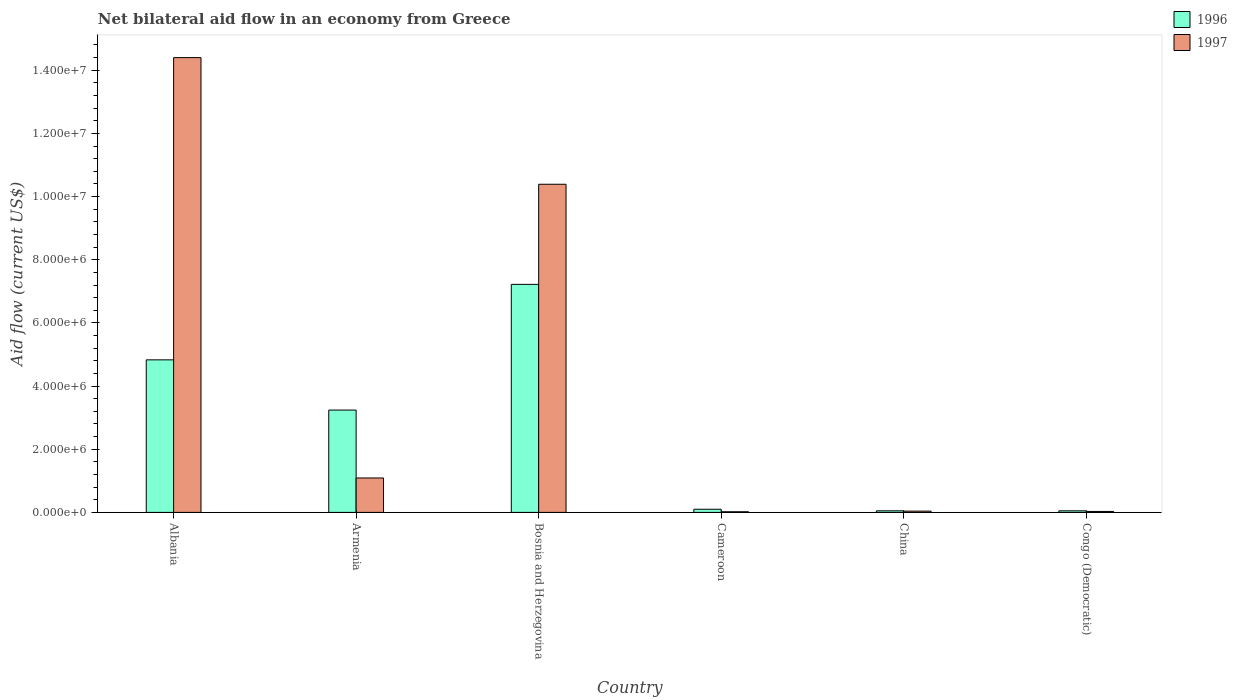How many different coloured bars are there?
Offer a very short reply. 2. How many groups of bars are there?
Your answer should be very brief. 6. Are the number of bars per tick equal to the number of legend labels?
Offer a very short reply. Yes. Are the number of bars on each tick of the X-axis equal?
Keep it short and to the point. Yes. How many bars are there on the 5th tick from the left?
Ensure brevity in your answer.  2. What is the label of the 5th group of bars from the left?
Offer a very short reply. China. In how many cases, is the number of bars for a given country not equal to the number of legend labels?
Keep it short and to the point. 0. What is the net bilateral aid flow in 1997 in Bosnia and Herzegovina?
Offer a very short reply. 1.04e+07. Across all countries, what is the maximum net bilateral aid flow in 1997?
Your answer should be compact. 1.44e+07. Across all countries, what is the minimum net bilateral aid flow in 1996?
Your answer should be very brief. 5.00e+04. In which country was the net bilateral aid flow in 1996 maximum?
Provide a succinct answer. Bosnia and Herzegovina. In which country was the net bilateral aid flow in 1996 minimum?
Provide a short and direct response. China. What is the total net bilateral aid flow in 1997 in the graph?
Offer a terse response. 2.60e+07. What is the difference between the net bilateral aid flow in 1997 in Armenia and that in Bosnia and Herzegovina?
Your answer should be compact. -9.30e+06. What is the difference between the net bilateral aid flow in 1996 in China and the net bilateral aid flow in 1997 in Armenia?
Provide a short and direct response. -1.04e+06. What is the average net bilateral aid flow in 1996 per country?
Your response must be concise. 2.58e+06. What is the difference between the net bilateral aid flow of/in 1997 and net bilateral aid flow of/in 1996 in Cameroon?
Provide a short and direct response. -8.00e+04. In how many countries, is the net bilateral aid flow in 1997 greater than 4800000 US$?
Keep it short and to the point. 2. What is the ratio of the net bilateral aid flow in 1997 in Albania to that in Cameroon?
Provide a succinct answer. 720. Is the net bilateral aid flow in 1997 in Cameroon less than that in China?
Make the answer very short. Yes. What is the difference between the highest and the second highest net bilateral aid flow in 1997?
Your answer should be very brief. 4.01e+06. What is the difference between the highest and the lowest net bilateral aid flow in 1996?
Your response must be concise. 7.17e+06. In how many countries, is the net bilateral aid flow in 1996 greater than the average net bilateral aid flow in 1996 taken over all countries?
Offer a terse response. 3. Is the sum of the net bilateral aid flow in 1997 in Armenia and Congo (Democratic) greater than the maximum net bilateral aid flow in 1996 across all countries?
Provide a short and direct response. No. What does the 2nd bar from the left in Bosnia and Herzegovina represents?
Give a very brief answer. 1997. How many bars are there?
Your answer should be very brief. 12. Are all the bars in the graph horizontal?
Your answer should be compact. No. Are the values on the major ticks of Y-axis written in scientific E-notation?
Provide a succinct answer. Yes. Does the graph contain any zero values?
Offer a terse response. No. Does the graph contain grids?
Offer a very short reply. No. How are the legend labels stacked?
Offer a terse response. Vertical. What is the title of the graph?
Your answer should be compact. Net bilateral aid flow in an economy from Greece. Does "2001" appear as one of the legend labels in the graph?
Your answer should be compact. No. What is the label or title of the X-axis?
Provide a short and direct response. Country. What is the label or title of the Y-axis?
Give a very brief answer. Aid flow (current US$). What is the Aid flow (current US$) of 1996 in Albania?
Your answer should be compact. 4.83e+06. What is the Aid flow (current US$) of 1997 in Albania?
Provide a short and direct response. 1.44e+07. What is the Aid flow (current US$) in 1996 in Armenia?
Offer a very short reply. 3.24e+06. What is the Aid flow (current US$) in 1997 in Armenia?
Give a very brief answer. 1.09e+06. What is the Aid flow (current US$) of 1996 in Bosnia and Herzegovina?
Provide a short and direct response. 7.22e+06. What is the Aid flow (current US$) of 1997 in Bosnia and Herzegovina?
Provide a succinct answer. 1.04e+07. What is the Aid flow (current US$) in 1997 in China?
Your response must be concise. 4.00e+04. What is the Aid flow (current US$) in 1996 in Congo (Democratic)?
Your answer should be very brief. 5.00e+04. Across all countries, what is the maximum Aid flow (current US$) in 1996?
Offer a very short reply. 7.22e+06. Across all countries, what is the maximum Aid flow (current US$) in 1997?
Keep it short and to the point. 1.44e+07. What is the total Aid flow (current US$) in 1996 in the graph?
Provide a succinct answer. 1.55e+07. What is the total Aid flow (current US$) of 1997 in the graph?
Offer a very short reply. 2.60e+07. What is the difference between the Aid flow (current US$) of 1996 in Albania and that in Armenia?
Provide a succinct answer. 1.59e+06. What is the difference between the Aid flow (current US$) in 1997 in Albania and that in Armenia?
Keep it short and to the point. 1.33e+07. What is the difference between the Aid flow (current US$) of 1996 in Albania and that in Bosnia and Herzegovina?
Offer a very short reply. -2.39e+06. What is the difference between the Aid flow (current US$) in 1997 in Albania and that in Bosnia and Herzegovina?
Offer a terse response. 4.01e+06. What is the difference between the Aid flow (current US$) of 1996 in Albania and that in Cameroon?
Make the answer very short. 4.73e+06. What is the difference between the Aid flow (current US$) of 1997 in Albania and that in Cameroon?
Give a very brief answer. 1.44e+07. What is the difference between the Aid flow (current US$) in 1996 in Albania and that in China?
Make the answer very short. 4.78e+06. What is the difference between the Aid flow (current US$) in 1997 in Albania and that in China?
Your answer should be compact. 1.44e+07. What is the difference between the Aid flow (current US$) of 1996 in Albania and that in Congo (Democratic)?
Make the answer very short. 4.78e+06. What is the difference between the Aid flow (current US$) of 1997 in Albania and that in Congo (Democratic)?
Your response must be concise. 1.44e+07. What is the difference between the Aid flow (current US$) of 1996 in Armenia and that in Bosnia and Herzegovina?
Provide a short and direct response. -3.98e+06. What is the difference between the Aid flow (current US$) of 1997 in Armenia and that in Bosnia and Herzegovina?
Give a very brief answer. -9.30e+06. What is the difference between the Aid flow (current US$) of 1996 in Armenia and that in Cameroon?
Keep it short and to the point. 3.14e+06. What is the difference between the Aid flow (current US$) of 1997 in Armenia and that in Cameroon?
Make the answer very short. 1.07e+06. What is the difference between the Aid flow (current US$) of 1996 in Armenia and that in China?
Offer a terse response. 3.19e+06. What is the difference between the Aid flow (current US$) in 1997 in Armenia and that in China?
Your answer should be compact. 1.05e+06. What is the difference between the Aid flow (current US$) in 1996 in Armenia and that in Congo (Democratic)?
Make the answer very short. 3.19e+06. What is the difference between the Aid flow (current US$) in 1997 in Armenia and that in Congo (Democratic)?
Offer a very short reply. 1.06e+06. What is the difference between the Aid flow (current US$) in 1996 in Bosnia and Herzegovina and that in Cameroon?
Ensure brevity in your answer.  7.12e+06. What is the difference between the Aid flow (current US$) in 1997 in Bosnia and Herzegovina and that in Cameroon?
Keep it short and to the point. 1.04e+07. What is the difference between the Aid flow (current US$) of 1996 in Bosnia and Herzegovina and that in China?
Your answer should be very brief. 7.17e+06. What is the difference between the Aid flow (current US$) of 1997 in Bosnia and Herzegovina and that in China?
Your response must be concise. 1.04e+07. What is the difference between the Aid flow (current US$) of 1996 in Bosnia and Herzegovina and that in Congo (Democratic)?
Offer a terse response. 7.17e+06. What is the difference between the Aid flow (current US$) of 1997 in Bosnia and Herzegovina and that in Congo (Democratic)?
Offer a terse response. 1.04e+07. What is the difference between the Aid flow (current US$) of 1996 in Cameroon and that in China?
Give a very brief answer. 5.00e+04. What is the difference between the Aid flow (current US$) in 1997 in Cameroon and that in China?
Make the answer very short. -2.00e+04. What is the difference between the Aid flow (current US$) of 1997 in Cameroon and that in Congo (Democratic)?
Ensure brevity in your answer.  -10000. What is the difference between the Aid flow (current US$) in 1996 in China and that in Congo (Democratic)?
Ensure brevity in your answer.  0. What is the difference between the Aid flow (current US$) in 1996 in Albania and the Aid flow (current US$) in 1997 in Armenia?
Ensure brevity in your answer.  3.74e+06. What is the difference between the Aid flow (current US$) in 1996 in Albania and the Aid flow (current US$) in 1997 in Bosnia and Herzegovina?
Keep it short and to the point. -5.56e+06. What is the difference between the Aid flow (current US$) of 1996 in Albania and the Aid flow (current US$) of 1997 in Cameroon?
Provide a succinct answer. 4.81e+06. What is the difference between the Aid flow (current US$) of 1996 in Albania and the Aid flow (current US$) of 1997 in China?
Ensure brevity in your answer.  4.79e+06. What is the difference between the Aid flow (current US$) of 1996 in Albania and the Aid flow (current US$) of 1997 in Congo (Democratic)?
Your answer should be compact. 4.80e+06. What is the difference between the Aid flow (current US$) of 1996 in Armenia and the Aid flow (current US$) of 1997 in Bosnia and Herzegovina?
Your answer should be compact. -7.15e+06. What is the difference between the Aid flow (current US$) of 1996 in Armenia and the Aid flow (current US$) of 1997 in Cameroon?
Keep it short and to the point. 3.22e+06. What is the difference between the Aid flow (current US$) in 1996 in Armenia and the Aid flow (current US$) in 1997 in China?
Give a very brief answer. 3.20e+06. What is the difference between the Aid flow (current US$) in 1996 in Armenia and the Aid flow (current US$) in 1997 in Congo (Democratic)?
Keep it short and to the point. 3.21e+06. What is the difference between the Aid flow (current US$) of 1996 in Bosnia and Herzegovina and the Aid flow (current US$) of 1997 in Cameroon?
Make the answer very short. 7.20e+06. What is the difference between the Aid flow (current US$) of 1996 in Bosnia and Herzegovina and the Aid flow (current US$) of 1997 in China?
Ensure brevity in your answer.  7.18e+06. What is the difference between the Aid flow (current US$) of 1996 in Bosnia and Herzegovina and the Aid flow (current US$) of 1997 in Congo (Democratic)?
Your response must be concise. 7.19e+06. What is the difference between the Aid flow (current US$) in 1996 in Cameroon and the Aid flow (current US$) in 1997 in Congo (Democratic)?
Offer a very short reply. 7.00e+04. What is the difference between the Aid flow (current US$) in 1996 in China and the Aid flow (current US$) in 1997 in Congo (Democratic)?
Your answer should be very brief. 2.00e+04. What is the average Aid flow (current US$) of 1996 per country?
Provide a short and direct response. 2.58e+06. What is the average Aid flow (current US$) of 1997 per country?
Offer a very short reply. 4.33e+06. What is the difference between the Aid flow (current US$) of 1996 and Aid flow (current US$) of 1997 in Albania?
Keep it short and to the point. -9.57e+06. What is the difference between the Aid flow (current US$) in 1996 and Aid flow (current US$) in 1997 in Armenia?
Your answer should be compact. 2.15e+06. What is the difference between the Aid flow (current US$) in 1996 and Aid flow (current US$) in 1997 in Bosnia and Herzegovina?
Make the answer very short. -3.17e+06. What is the difference between the Aid flow (current US$) in 1996 and Aid flow (current US$) in 1997 in Cameroon?
Keep it short and to the point. 8.00e+04. What is the ratio of the Aid flow (current US$) in 1996 in Albania to that in Armenia?
Provide a succinct answer. 1.49. What is the ratio of the Aid flow (current US$) in 1997 in Albania to that in Armenia?
Make the answer very short. 13.21. What is the ratio of the Aid flow (current US$) of 1996 in Albania to that in Bosnia and Herzegovina?
Provide a succinct answer. 0.67. What is the ratio of the Aid flow (current US$) of 1997 in Albania to that in Bosnia and Herzegovina?
Make the answer very short. 1.39. What is the ratio of the Aid flow (current US$) in 1996 in Albania to that in Cameroon?
Your response must be concise. 48.3. What is the ratio of the Aid flow (current US$) of 1997 in Albania to that in Cameroon?
Provide a succinct answer. 720. What is the ratio of the Aid flow (current US$) of 1996 in Albania to that in China?
Make the answer very short. 96.6. What is the ratio of the Aid flow (current US$) of 1997 in Albania to that in China?
Give a very brief answer. 360. What is the ratio of the Aid flow (current US$) of 1996 in Albania to that in Congo (Democratic)?
Your answer should be very brief. 96.6. What is the ratio of the Aid flow (current US$) of 1997 in Albania to that in Congo (Democratic)?
Offer a terse response. 480. What is the ratio of the Aid flow (current US$) of 1996 in Armenia to that in Bosnia and Herzegovina?
Your answer should be very brief. 0.45. What is the ratio of the Aid flow (current US$) in 1997 in Armenia to that in Bosnia and Herzegovina?
Keep it short and to the point. 0.1. What is the ratio of the Aid flow (current US$) in 1996 in Armenia to that in Cameroon?
Make the answer very short. 32.4. What is the ratio of the Aid flow (current US$) in 1997 in Armenia to that in Cameroon?
Your response must be concise. 54.5. What is the ratio of the Aid flow (current US$) of 1996 in Armenia to that in China?
Provide a succinct answer. 64.8. What is the ratio of the Aid flow (current US$) in 1997 in Armenia to that in China?
Provide a short and direct response. 27.25. What is the ratio of the Aid flow (current US$) of 1996 in Armenia to that in Congo (Democratic)?
Your answer should be compact. 64.8. What is the ratio of the Aid flow (current US$) of 1997 in Armenia to that in Congo (Democratic)?
Make the answer very short. 36.33. What is the ratio of the Aid flow (current US$) in 1996 in Bosnia and Herzegovina to that in Cameroon?
Make the answer very short. 72.2. What is the ratio of the Aid flow (current US$) in 1997 in Bosnia and Herzegovina to that in Cameroon?
Provide a succinct answer. 519.5. What is the ratio of the Aid flow (current US$) in 1996 in Bosnia and Herzegovina to that in China?
Offer a terse response. 144.4. What is the ratio of the Aid flow (current US$) of 1997 in Bosnia and Herzegovina to that in China?
Your response must be concise. 259.75. What is the ratio of the Aid flow (current US$) of 1996 in Bosnia and Herzegovina to that in Congo (Democratic)?
Keep it short and to the point. 144.4. What is the ratio of the Aid flow (current US$) of 1997 in Bosnia and Herzegovina to that in Congo (Democratic)?
Provide a short and direct response. 346.33. What is the ratio of the Aid flow (current US$) in 1996 in Cameroon to that in China?
Give a very brief answer. 2. What is the ratio of the Aid flow (current US$) of 1997 in Cameroon to that in China?
Your answer should be compact. 0.5. What is the ratio of the Aid flow (current US$) in 1997 in Cameroon to that in Congo (Democratic)?
Offer a very short reply. 0.67. What is the ratio of the Aid flow (current US$) of 1996 in China to that in Congo (Democratic)?
Ensure brevity in your answer.  1. What is the difference between the highest and the second highest Aid flow (current US$) in 1996?
Provide a succinct answer. 2.39e+06. What is the difference between the highest and the second highest Aid flow (current US$) of 1997?
Offer a terse response. 4.01e+06. What is the difference between the highest and the lowest Aid flow (current US$) of 1996?
Your answer should be very brief. 7.17e+06. What is the difference between the highest and the lowest Aid flow (current US$) of 1997?
Keep it short and to the point. 1.44e+07. 